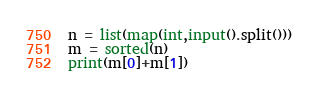<code> <loc_0><loc_0><loc_500><loc_500><_Python_>n = list(map(int,input().split()))
m = sorted(n)
print(m[0]+m[1])</code> 